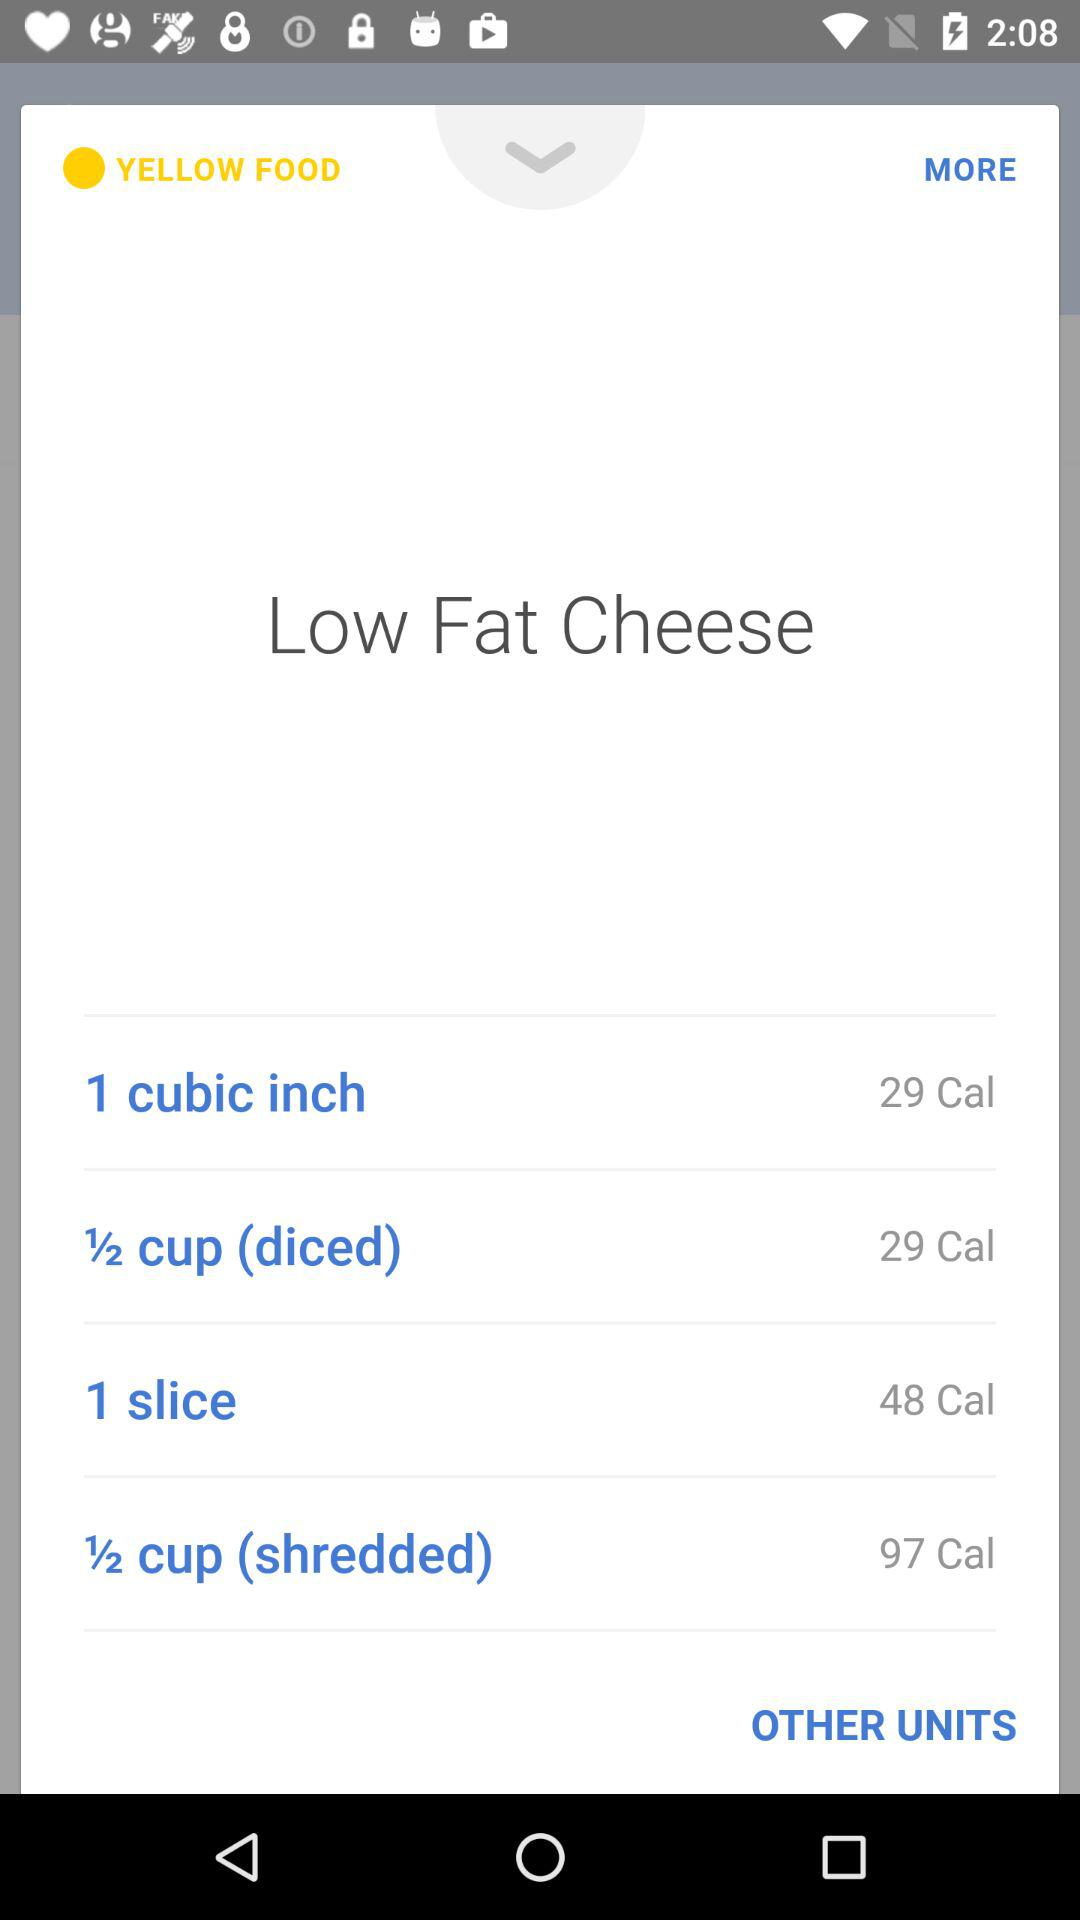How many calories does one cubic inch contain? One cubic inch contains 29 calories. 